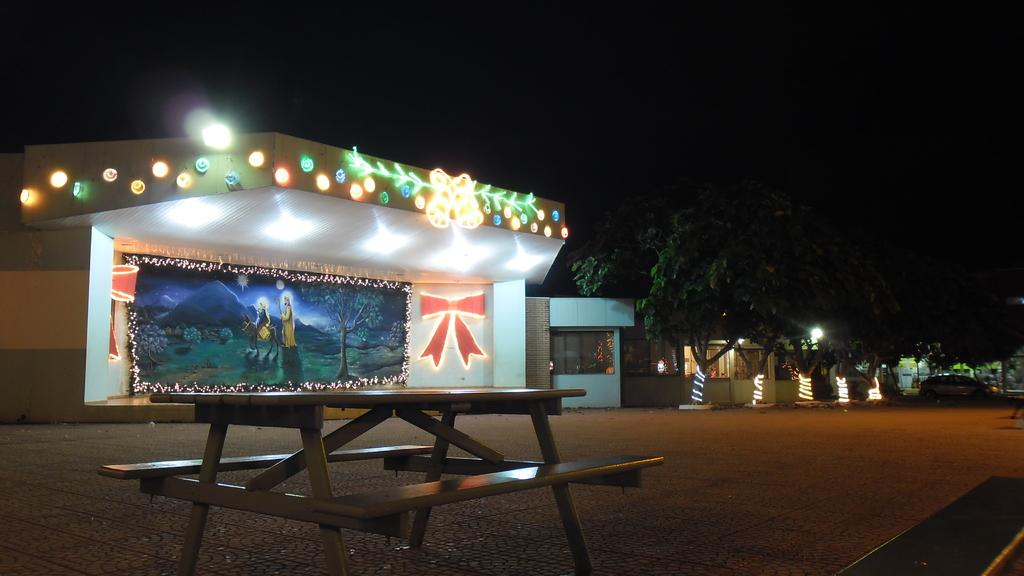What is located in the center of the image? There are buildings in the center of the image. What type of lighting can be seen in the image? Decor lights are visible in the image. What type of vegetation is on the right side of the image? There are trees on the right side of the image. What type of vehicle is present on the right side of the image? A car is present on the right side of the image. What type of seating is at the bottom of the image? There is a bench at the bottom of the image. Where is the shelf located in the image? There is no shelf present in the image. Can you tell me how many giraffes are depicted in the image? There are no giraffes depicted in the image. 